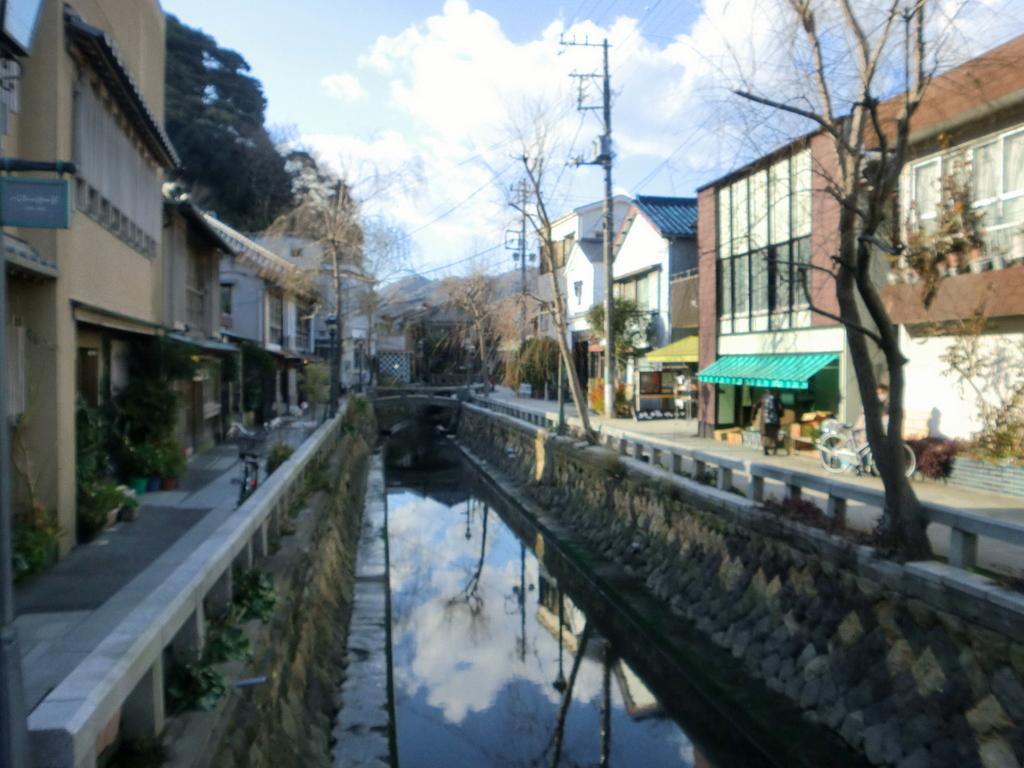Describe this image in one or two sentences. In this picture I can see there is a canal and there is water in it. There is a bicycle and a person standing on the right side, there is another person standing behind him, there are few plants, buildings and trees. There is another bicycle on left side and there are a few buildings and trees. 